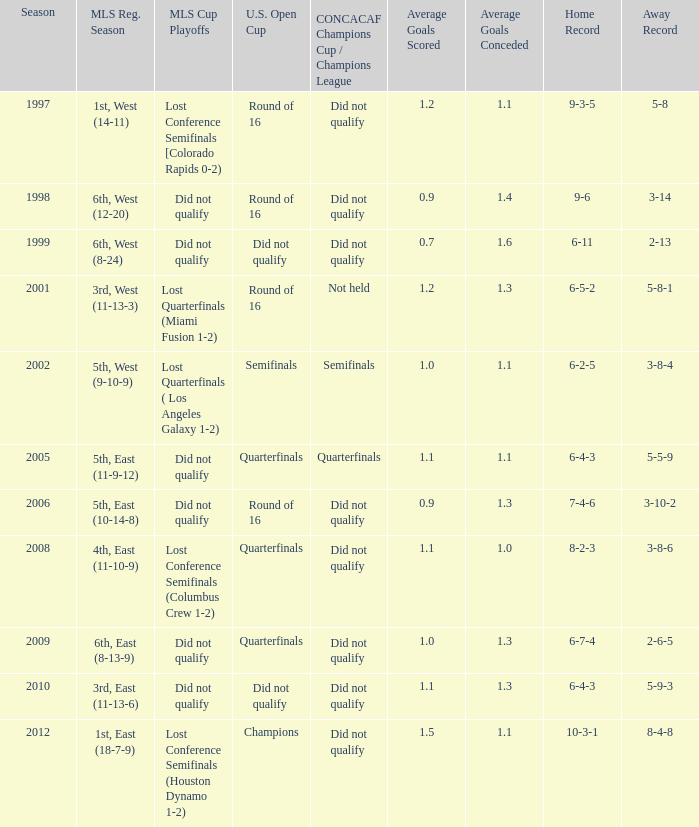How did the team place when they did not qualify for the Concaf Champions Cup but made it to Round of 16 in the U.S. Open Cup? Lost Conference Semifinals [Colorado Rapids 0-2), Did not qualify, Did not qualify. 